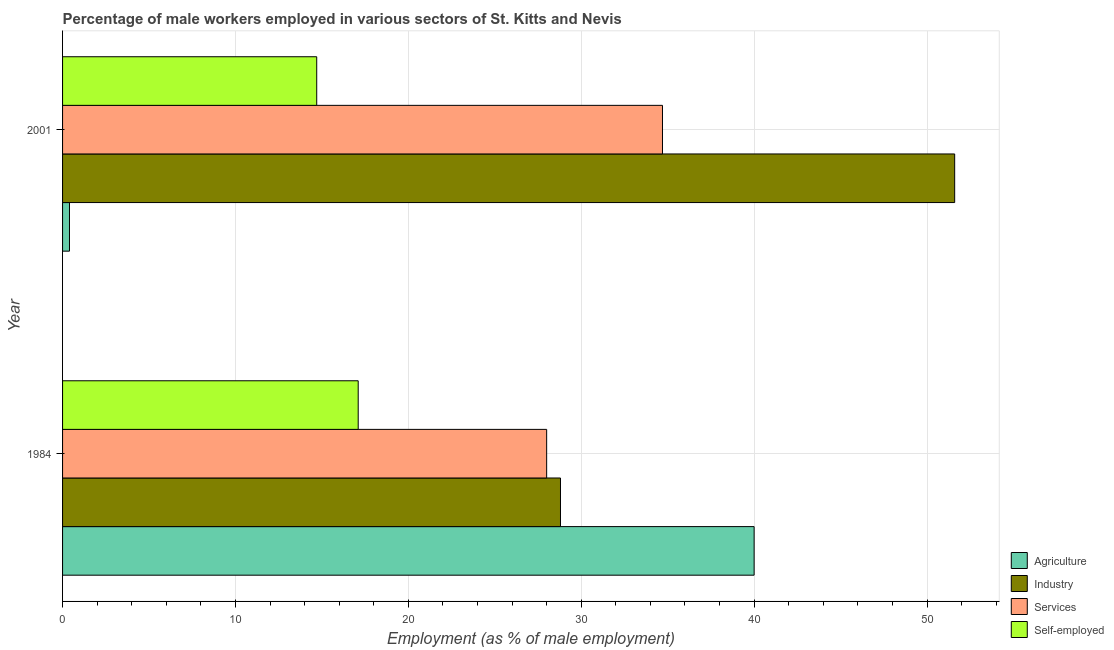How many groups of bars are there?
Your answer should be compact. 2. Are the number of bars per tick equal to the number of legend labels?
Keep it short and to the point. Yes. How many bars are there on the 2nd tick from the bottom?
Provide a short and direct response. 4. Across all years, what is the maximum percentage of self employed male workers?
Ensure brevity in your answer.  17.1. Across all years, what is the minimum percentage of self employed male workers?
Offer a very short reply. 14.7. In which year was the percentage of male workers in services minimum?
Make the answer very short. 1984. What is the total percentage of self employed male workers in the graph?
Your response must be concise. 31.8. What is the difference between the percentage of male workers in services in 1984 and that in 2001?
Make the answer very short. -6.7. What is the difference between the percentage of male workers in agriculture in 2001 and the percentage of self employed male workers in 1984?
Your answer should be compact. -16.7. What is the average percentage of male workers in services per year?
Offer a very short reply. 31.35. In the year 2001, what is the difference between the percentage of self employed male workers and percentage of male workers in industry?
Your answer should be compact. -36.9. What is the ratio of the percentage of male workers in industry in 1984 to that in 2001?
Provide a succinct answer. 0.56. Is the percentage of self employed male workers in 1984 less than that in 2001?
Ensure brevity in your answer.  No. Is the difference between the percentage of self employed male workers in 1984 and 2001 greater than the difference between the percentage of male workers in industry in 1984 and 2001?
Provide a short and direct response. Yes. In how many years, is the percentage of male workers in services greater than the average percentage of male workers in services taken over all years?
Keep it short and to the point. 1. What does the 1st bar from the top in 2001 represents?
Make the answer very short. Self-employed. What does the 4th bar from the bottom in 2001 represents?
Offer a very short reply. Self-employed. Is it the case that in every year, the sum of the percentage of male workers in agriculture and percentage of male workers in industry is greater than the percentage of male workers in services?
Offer a terse response. Yes. How many bars are there?
Ensure brevity in your answer.  8. What is the difference between two consecutive major ticks on the X-axis?
Offer a terse response. 10. Are the values on the major ticks of X-axis written in scientific E-notation?
Give a very brief answer. No. Does the graph contain any zero values?
Your answer should be very brief. No. Where does the legend appear in the graph?
Provide a short and direct response. Bottom right. How are the legend labels stacked?
Your answer should be very brief. Vertical. What is the title of the graph?
Provide a short and direct response. Percentage of male workers employed in various sectors of St. Kitts and Nevis. Does "Italy" appear as one of the legend labels in the graph?
Offer a very short reply. No. What is the label or title of the X-axis?
Your answer should be very brief. Employment (as % of male employment). What is the label or title of the Y-axis?
Keep it short and to the point. Year. What is the Employment (as % of male employment) in Agriculture in 1984?
Keep it short and to the point. 40. What is the Employment (as % of male employment) of Industry in 1984?
Provide a short and direct response. 28.8. What is the Employment (as % of male employment) of Services in 1984?
Ensure brevity in your answer.  28. What is the Employment (as % of male employment) of Self-employed in 1984?
Provide a short and direct response. 17.1. What is the Employment (as % of male employment) of Agriculture in 2001?
Keep it short and to the point. 0.4. What is the Employment (as % of male employment) of Industry in 2001?
Provide a short and direct response. 51.6. What is the Employment (as % of male employment) in Services in 2001?
Offer a very short reply. 34.7. What is the Employment (as % of male employment) in Self-employed in 2001?
Keep it short and to the point. 14.7. Across all years, what is the maximum Employment (as % of male employment) in Industry?
Your answer should be very brief. 51.6. Across all years, what is the maximum Employment (as % of male employment) of Services?
Give a very brief answer. 34.7. Across all years, what is the maximum Employment (as % of male employment) of Self-employed?
Offer a terse response. 17.1. Across all years, what is the minimum Employment (as % of male employment) in Agriculture?
Give a very brief answer. 0.4. Across all years, what is the minimum Employment (as % of male employment) of Industry?
Provide a succinct answer. 28.8. Across all years, what is the minimum Employment (as % of male employment) in Services?
Ensure brevity in your answer.  28. Across all years, what is the minimum Employment (as % of male employment) in Self-employed?
Offer a very short reply. 14.7. What is the total Employment (as % of male employment) of Agriculture in the graph?
Offer a terse response. 40.4. What is the total Employment (as % of male employment) in Industry in the graph?
Provide a short and direct response. 80.4. What is the total Employment (as % of male employment) in Services in the graph?
Make the answer very short. 62.7. What is the total Employment (as % of male employment) of Self-employed in the graph?
Make the answer very short. 31.8. What is the difference between the Employment (as % of male employment) of Agriculture in 1984 and that in 2001?
Your answer should be compact. 39.6. What is the difference between the Employment (as % of male employment) of Industry in 1984 and that in 2001?
Keep it short and to the point. -22.8. What is the difference between the Employment (as % of male employment) in Services in 1984 and that in 2001?
Ensure brevity in your answer.  -6.7. What is the difference between the Employment (as % of male employment) in Agriculture in 1984 and the Employment (as % of male employment) in Industry in 2001?
Your response must be concise. -11.6. What is the difference between the Employment (as % of male employment) in Agriculture in 1984 and the Employment (as % of male employment) in Self-employed in 2001?
Ensure brevity in your answer.  25.3. What is the difference between the Employment (as % of male employment) in Industry in 1984 and the Employment (as % of male employment) in Services in 2001?
Give a very brief answer. -5.9. What is the average Employment (as % of male employment) in Agriculture per year?
Your answer should be very brief. 20.2. What is the average Employment (as % of male employment) in Industry per year?
Ensure brevity in your answer.  40.2. What is the average Employment (as % of male employment) in Services per year?
Your answer should be very brief. 31.35. In the year 1984, what is the difference between the Employment (as % of male employment) of Agriculture and Employment (as % of male employment) of Services?
Keep it short and to the point. 12. In the year 1984, what is the difference between the Employment (as % of male employment) in Agriculture and Employment (as % of male employment) in Self-employed?
Give a very brief answer. 22.9. In the year 1984, what is the difference between the Employment (as % of male employment) in Services and Employment (as % of male employment) in Self-employed?
Make the answer very short. 10.9. In the year 2001, what is the difference between the Employment (as % of male employment) of Agriculture and Employment (as % of male employment) of Industry?
Your answer should be compact. -51.2. In the year 2001, what is the difference between the Employment (as % of male employment) of Agriculture and Employment (as % of male employment) of Services?
Provide a succinct answer. -34.3. In the year 2001, what is the difference between the Employment (as % of male employment) of Agriculture and Employment (as % of male employment) of Self-employed?
Your response must be concise. -14.3. In the year 2001, what is the difference between the Employment (as % of male employment) in Industry and Employment (as % of male employment) in Self-employed?
Ensure brevity in your answer.  36.9. In the year 2001, what is the difference between the Employment (as % of male employment) of Services and Employment (as % of male employment) of Self-employed?
Offer a terse response. 20. What is the ratio of the Employment (as % of male employment) of Agriculture in 1984 to that in 2001?
Provide a short and direct response. 100. What is the ratio of the Employment (as % of male employment) of Industry in 1984 to that in 2001?
Keep it short and to the point. 0.56. What is the ratio of the Employment (as % of male employment) in Services in 1984 to that in 2001?
Offer a very short reply. 0.81. What is the ratio of the Employment (as % of male employment) in Self-employed in 1984 to that in 2001?
Offer a very short reply. 1.16. What is the difference between the highest and the second highest Employment (as % of male employment) of Agriculture?
Provide a short and direct response. 39.6. What is the difference between the highest and the second highest Employment (as % of male employment) of Industry?
Give a very brief answer. 22.8. What is the difference between the highest and the second highest Employment (as % of male employment) of Services?
Your answer should be very brief. 6.7. What is the difference between the highest and the second highest Employment (as % of male employment) in Self-employed?
Provide a succinct answer. 2.4. What is the difference between the highest and the lowest Employment (as % of male employment) of Agriculture?
Make the answer very short. 39.6. What is the difference between the highest and the lowest Employment (as % of male employment) in Industry?
Keep it short and to the point. 22.8. What is the difference between the highest and the lowest Employment (as % of male employment) of Self-employed?
Offer a very short reply. 2.4. 